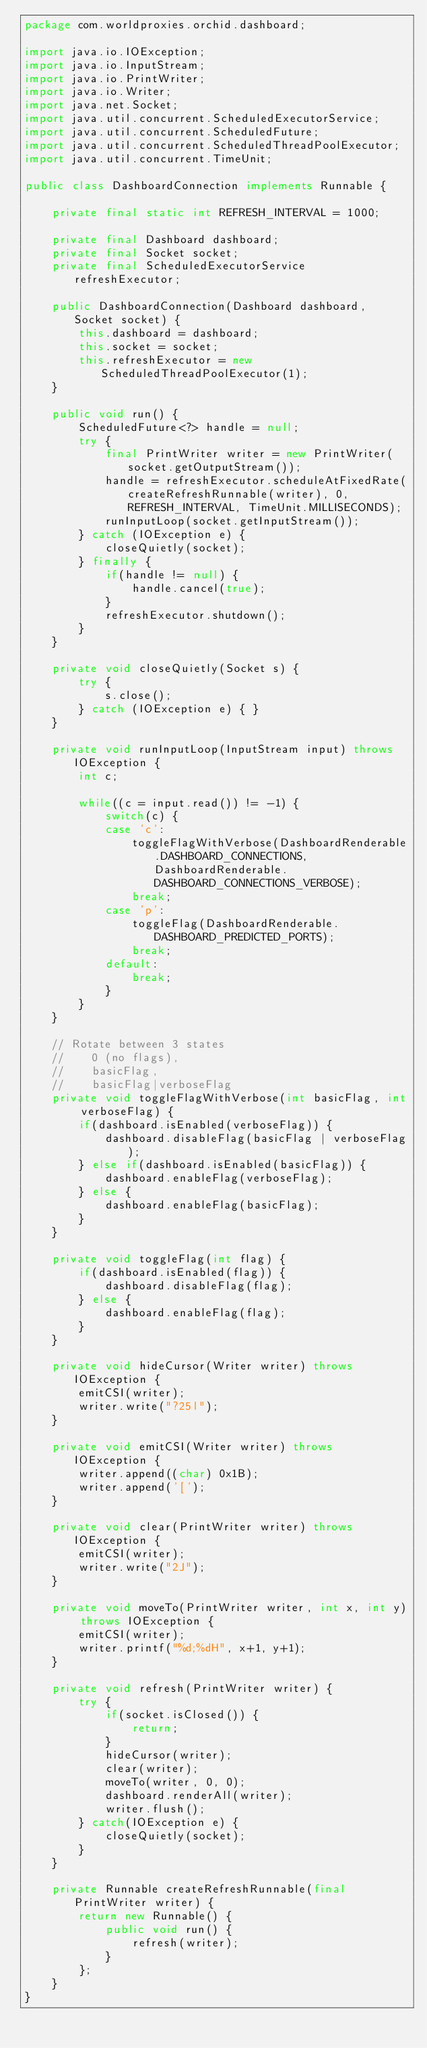<code> <loc_0><loc_0><loc_500><loc_500><_Java_>package com.worldproxies.orchid.dashboard;

import java.io.IOException;
import java.io.InputStream;
import java.io.PrintWriter;
import java.io.Writer;
import java.net.Socket;
import java.util.concurrent.ScheduledExecutorService;
import java.util.concurrent.ScheduledFuture;
import java.util.concurrent.ScheduledThreadPoolExecutor;
import java.util.concurrent.TimeUnit;

public class DashboardConnection implements Runnable {
	
	private final static int REFRESH_INTERVAL = 1000;

	private final Dashboard dashboard;
	private final Socket socket;
	private final ScheduledExecutorService refreshExecutor;
	
	public DashboardConnection(Dashboard dashboard, Socket socket) {
		this.dashboard = dashboard;
		this.socket = socket;
		this.refreshExecutor = new ScheduledThreadPoolExecutor(1);
	}

	public void run() {
		ScheduledFuture<?> handle = null;
		try {
			final PrintWriter writer = new PrintWriter(socket.getOutputStream());
			handle = refreshExecutor.scheduleAtFixedRate(createRefreshRunnable(writer), 0, REFRESH_INTERVAL, TimeUnit.MILLISECONDS);
			runInputLoop(socket.getInputStream());
		} catch (IOException e) {
			closeQuietly(socket);
		} finally {
			if(handle != null) {
				handle.cancel(true);
			}
			refreshExecutor.shutdown();
		}
	}

	private void closeQuietly(Socket s) {
		try {
			s.close();
		} catch (IOException e) { }
	}

	private void runInputLoop(InputStream input) throws IOException {
		int c;
		
		while((c = input.read()) != -1) {
			switch(c) {
			case 'c':
				toggleFlagWithVerbose(DashboardRenderable.DASHBOARD_CONNECTIONS, DashboardRenderable.DASHBOARD_CONNECTIONS_VERBOSE);
				break;
			case 'p':
				toggleFlag(DashboardRenderable.DASHBOARD_PREDICTED_PORTS);
				break;
			default:
				break;
			}
		}
	}

	// Rotate between 3 states
	//    0 (no flags),
	//    basicFlag,
	//    basicFlag|verboseFlag
	private void toggleFlagWithVerbose(int basicFlag, int verboseFlag) {
		if(dashboard.isEnabled(verboseFlag)) {
			dashboard.disableFlag(basicFlag | verboseFlag);
		} else if(dashboard.isEnabled(basicFlag)) {
			dashboard.enableFlag(verboseFlag);
		} else {
			dashboard.enableFlag(basicFlag);
		}
	}
	
	private void toggleFlag(int flag) {
		if(dashboard.isEnabled(flag)) {
			dashboard.disableFlag(flag);
		} else {
			dashboard.enableFlag(flag);
		}
	}

	private void hideCursor(Writer writer) throws IOException {
		emitCSI(writer);
		writer.write("?25l");
	}

	private void emitCSI(Writer writer) throws IOException {
		writer.append((char) 0x1B);
		writer.append('[');
	}
	
	private void clear(PrintWriter writer) throws IOException {
		emitCSI(writer);
		writer.write("2J");
	}
	
	private void moveTo(PrintWriter writer, int x, int y) throws IOException {
		emitCSI(writer);
		writer.printf("%d;%dH", x+1, y+1);
	}
	
	private void refresh(PrintWriter writer) {
		try {
			if(socket.isClosed()) {
				return;
			}
			hideCursor(writer);
			clear(writer);
			moveTo(writer, 0, 0);
			dashboard.renderAll(writer);
			writer.flush();
		} catch(IOException e) {
			closeQuietly(socket);
		}
	}

	private Runnable createRefreshRunnable(final PrintWriter writer) {
		return new Runnable() {
			public void run() {
				refresh(writer);
			}
		};
	}
}
</code> 